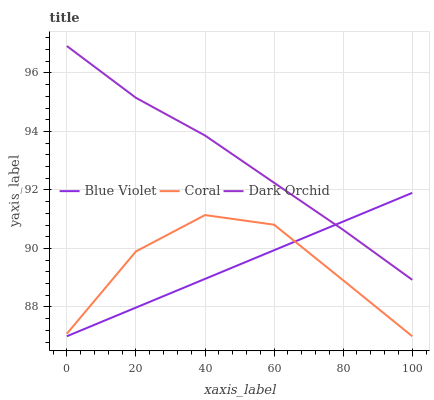Does Blue Violet have the minimum area under the curve?
Answer yes or no. Yes. Does Dark Orchid have the maximum area under the curve?
Answer yes or no. Yes. Does Dark Orchid have the minimum area under the curve?
Answer yes or no. No. Does Blue Violet have the maximum area under the curve?
Answer yes or no. No. Is Blue Violet the smoothest?
Answer yes or no. Yes. Is Coral the roughest?
Answer yes or no. Yes. Is Dark Orchid the smoothest?
Answer yes or no. No. Is Dark Orchid the roughest?
Answer yes or no. No. Does Coral have the lowest value?
Answer yes or no. Yes. Does Dark Orchid have the lowest value?
Answer yes or no. No. Does Dark Orchid have the highest value?
Answer yes or no. Yes. Does Blue Violet have the highest value?
Answer yes or no. No. Is Coral less than Dark Orchid?
Answer yes or no. Yes. Is Dark Orchid greater than Coral?
Answer yes or no. Yes. Does Blue Violet intersect Dark Orchid?
Answer yes or no. Yes. Is Blue Violet less than Dark Orchid?
Answer yes or no. No. Is Blue Violet greater than Dark Orchid?
Answer yes or no. No. Does Coral intersect Dark Orchid?
Answer yes or no. No. 